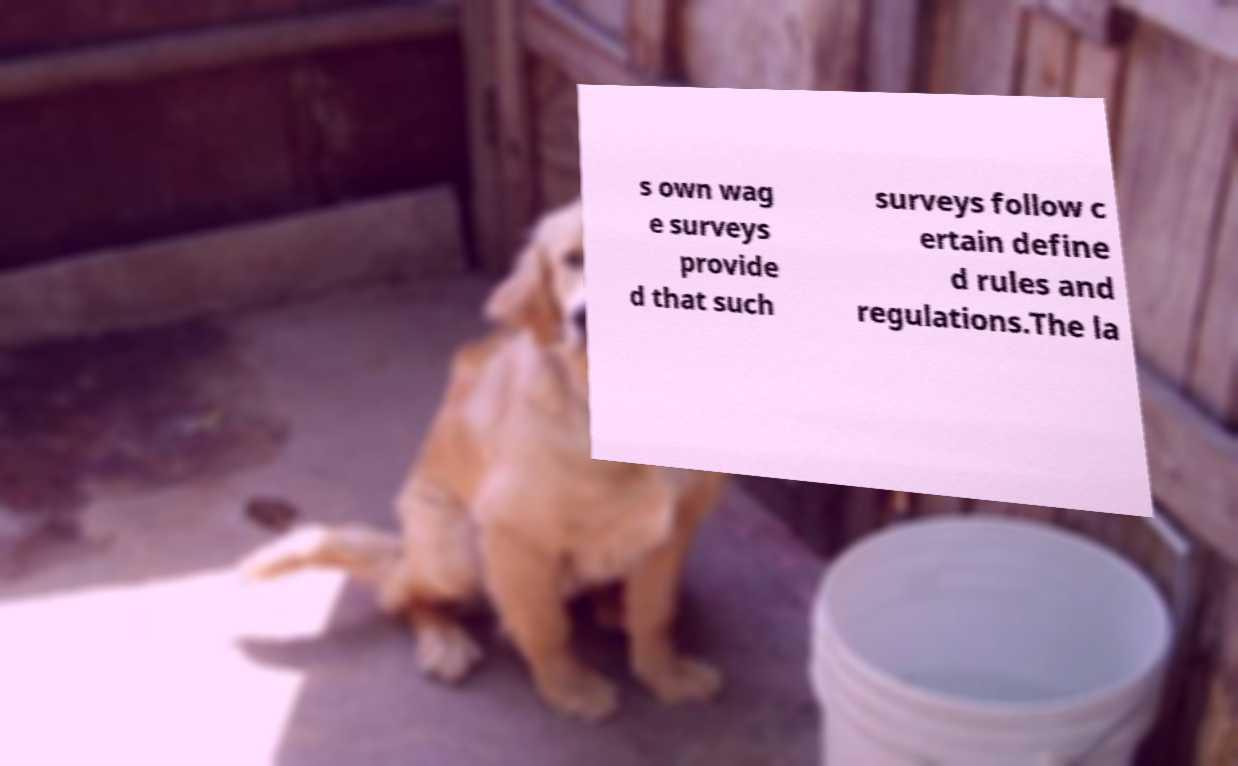What messages or text are displayed in this image? I need them in a readable, typed format. s own wag e surveys provide d that such surveys follow c ertain define d rules and regulations.The la 